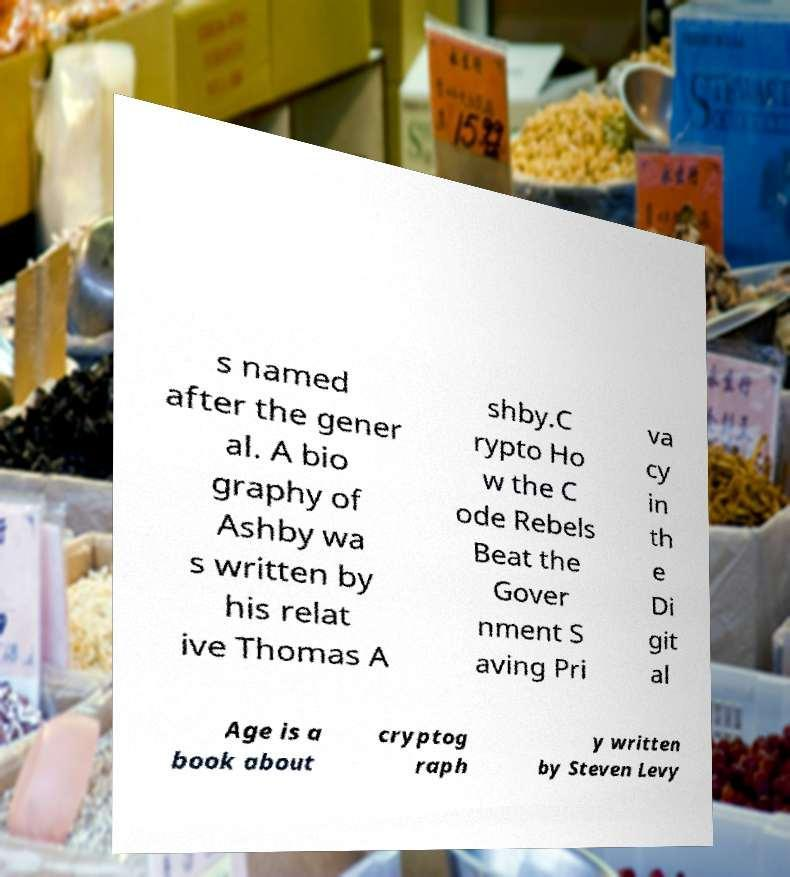Could you extract and type out the text from this image? s named after the gener al. A bio graphy of Ashby wa s written by his relat ive Thomas A shby.C rypto Ho w the C ode Rebels Beat the Gover nment S aving Pri va cy in th e Di git al Age is a book about cryptog raph y written by Steven Levy 